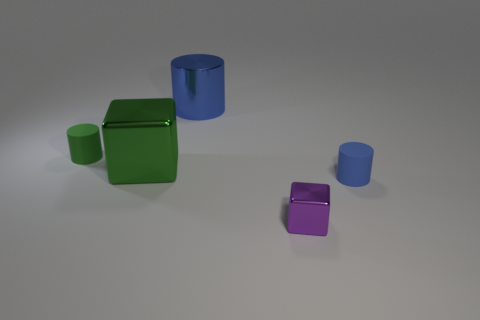How many different colors are present among the objects, and what do they signify? There are three distinct colors visible among the objects: green, blue, and purple. The green color is displayed on the large cube, blue on the two cylinders, and purple on the smaller cube. Colors in images can have various meanings, depending on the context. Here, they may simply serve to distinguish the objects from one another or to create a visually appealing composition through contrast and variety. 